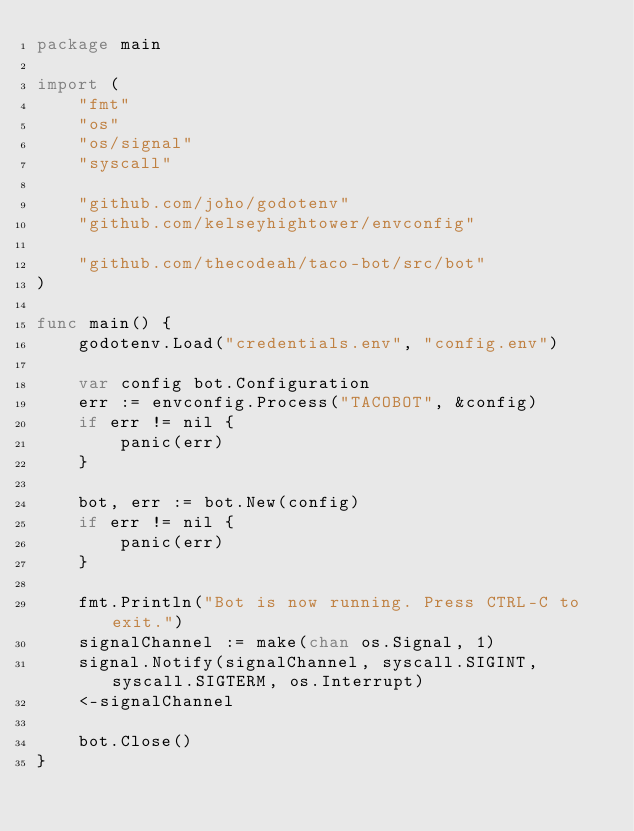<code> <loc_0><loc_0><loc_500><loc_500><_Go_>package main

import (
	"fmt"
	"os"
	"os/signal"
	"syscall"

	"github.com/joho/godotenv"
	"github.com/kelseyhightower/envconfig"

	"github.com/thecodeah/taco-bot/src/bot"
)

func main() {
	godotenv.Load("credentials.env", "config.env")

	var config bot.Configuration
	err := envconfig.Process("TACOBOT", &config)
	if err != nil {
		panic(err)
	}

	bot, err := bot.New(config)
	if err != nil {
		panic(err)
	}

	fmt.Println("Bot is now running. Press CTRL-C to exit.")
	signalChannel := make(chan os.Signal, 1)
	signal.Notify(signalChannel, syscall.SIGINT, syscall.SIGTERM, os.Interrupt)
	<-signalChannel

	bot.Close()
}
</code> 